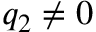Convert formula to latex. <formula><loc_0><loc_0><loc_500><loc_500>q _ { 2 } \neq 0</formula> 